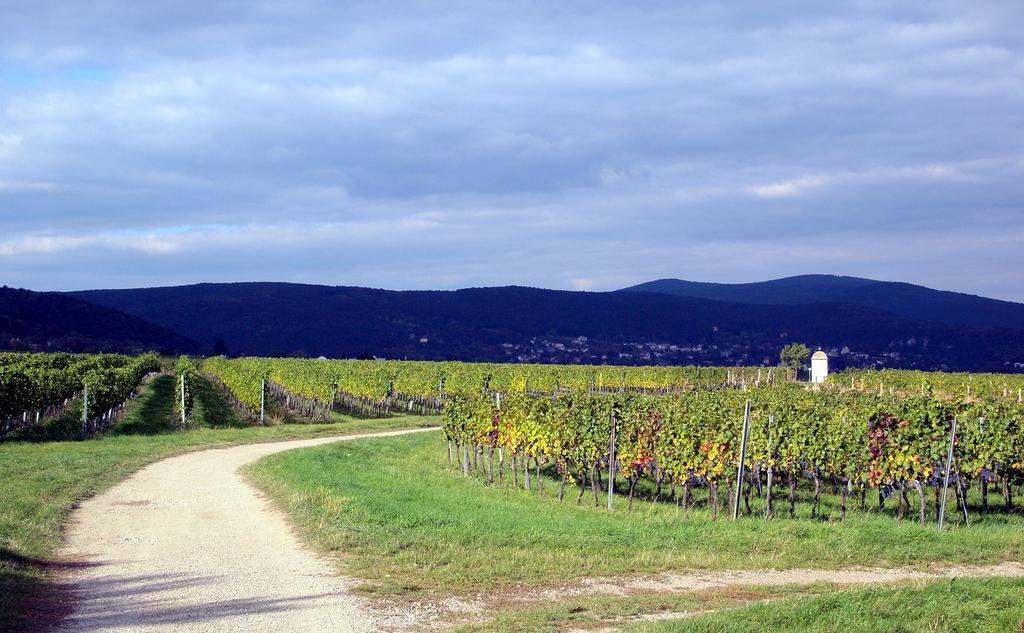What type of living organisms can be seen in the image? Plants can be seen in the image. What can be seen on the left side of the image? There is a path on the left side of the image. What is visible at the top of the image? The sky is visible at the top of the image. How many fingers can be seen in the image? There are no fingers visible in the image. What type of fowl is present in the image? There is no fowl present in the image. 